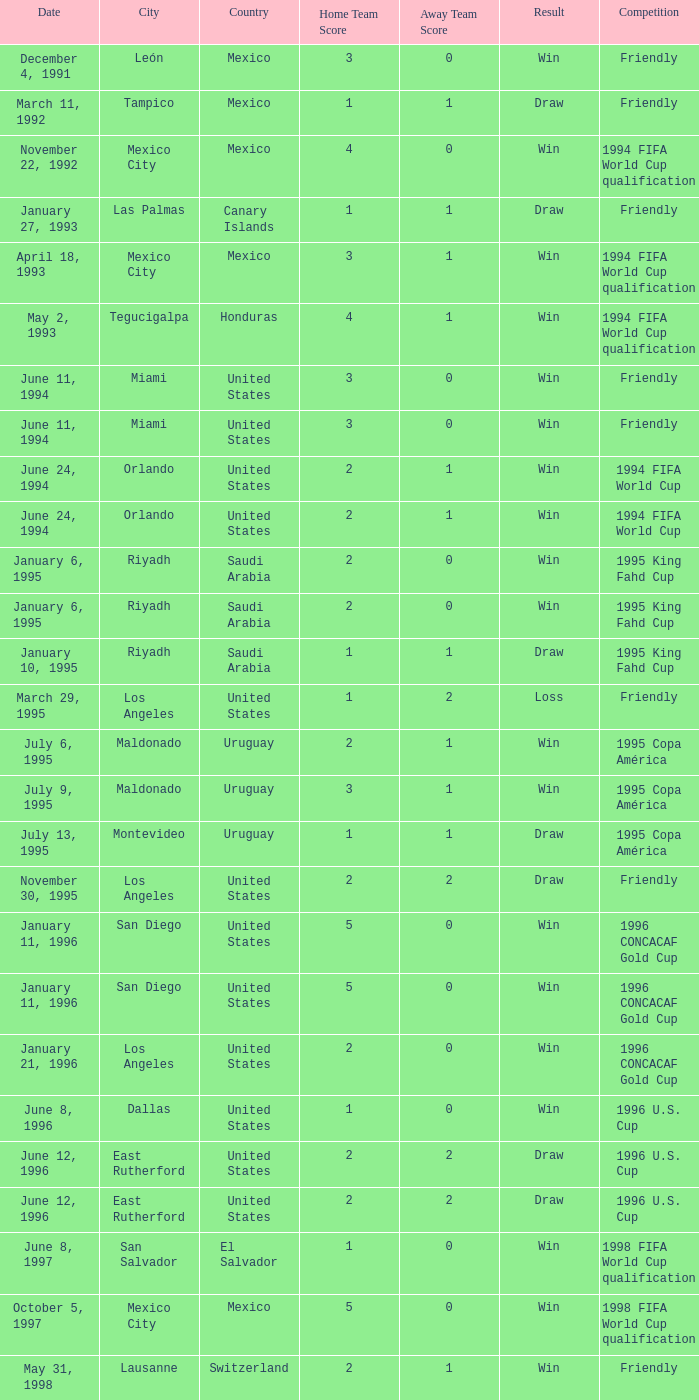What is Venue, when Date is "January 6, 1995"? Riyadh , Saudi Arabia, Riyadh, Saudi Arabia. 